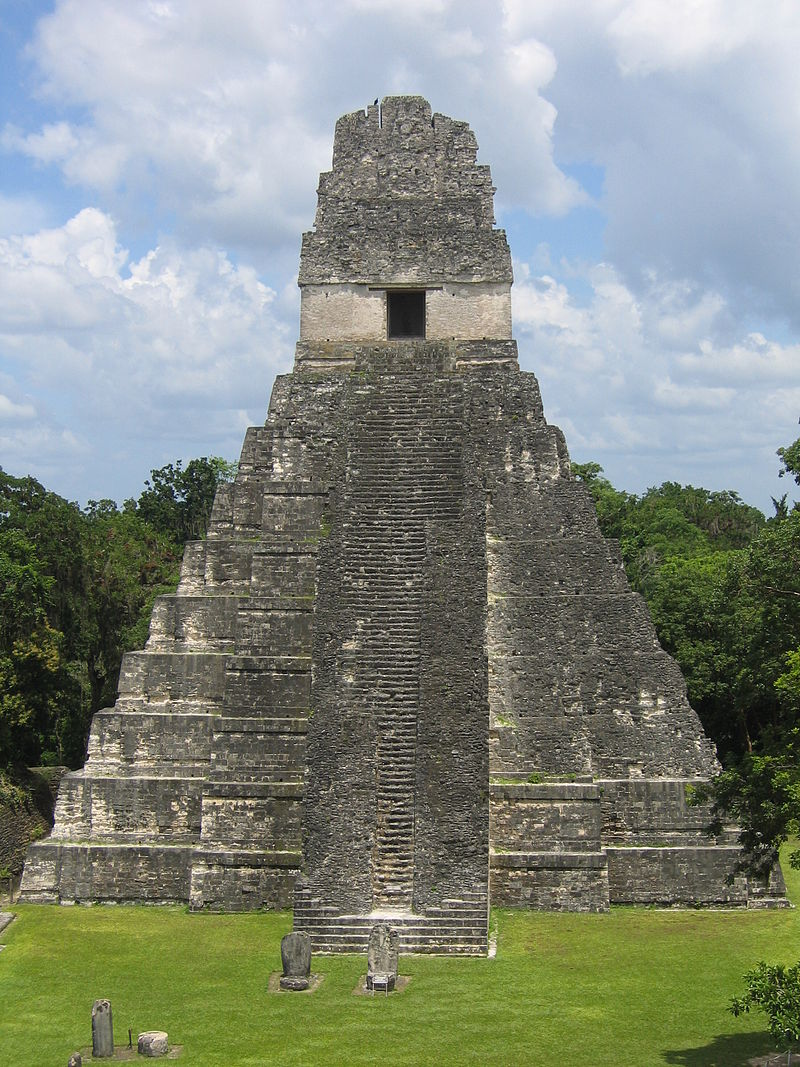How did the Mayans build such impressive structures without modern technology? The Mayans constructed their iconic structures using simple yet effective tools and innovative techniques. They employed tools made of stone, wood, and bones, leveraging manpower and natural resources to quarry massive stones and transport them to building sites. The precise alignment and cutting of stones were achieved through skilled craftsmanship and an understanding of geometry and astronomy. They also developed a system of ramps, levers, and pulleys to maneuver heavy materials. The labor was typically performed by a large workforce organized into specialized groups, demonstrating a high level of social organization and collective effort. 